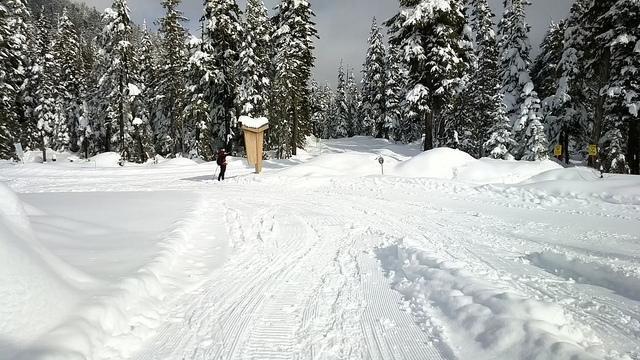How many donuts have a pumpkin face?
Give a very brief answer. 0. 